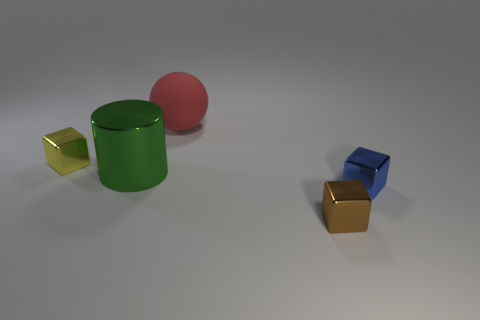What number of things are either blue metal blocks that are behind the brown metallic cube or tiny metallic things right of the brown shiny cube?
Ensure brevity in your answer.  1. Is the number of brown shiny things less than the number of tiny red metal balls?
Give a very brief answer. No. What shape is the other matte object that is the same size as the green thing?
Keep it short and to the point. Sphere. What number of red things are there?
Give a very brief answer. 1. What number of objects are in front of the rubber object and left of the small blue block?
Provide a short and direct response. 3. What material is the large ball?
Your response must be concise. Rubber. Are there any large green cylinders?
Ensure brevity in your answer.  Yes. There is a metallic block on the left side of the big matte thing; what is its color?
Make the answer very short. Yellow. There is a large thing that is in front of the tiny shiny thing that is behind the small blue metal thing; how many tiny blue objects are on the right side of it?
Your answer should be compact. 1. The tiny object that is both in front of the yellow cube and to the left of the small blue cube is made of what material?
Provide a short and direct response. Metal. 